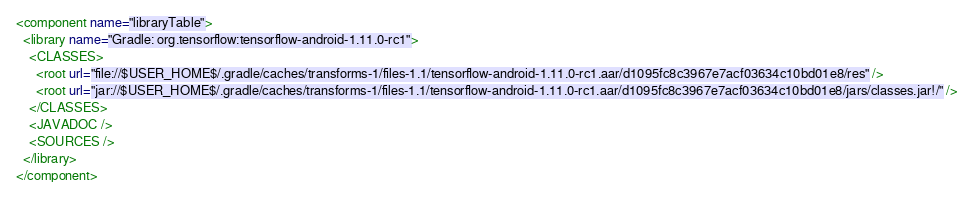<code> <loc_0><loc_0><loc_500><loc_500><_XML_><component name="libraryTable">
  <library name="Gradle: org.tensorflow:tensorflow-android-1.11.0-rc1">
    <CLASSES>
      <root url="file://$USER_HOME$/.gradle/caches/transforms-1/files-1.1/tensorflow-android-1.11.0-rc1.aar/d1095fc8c3967e7acf03634c10bd01e8/res" />
      <root url="jar://$USER_HOME$/.gradle/caches/transforms-1/files-1.1/tensorflow-android-1.11.0-rc1.aar/d1095fc8c3967e7acf03634c10bd01e8/jars/classes.jar!/" />
    </CLASSES>
    <JAVADOC />
    <SOURCES />
  </library>
</component></code> 